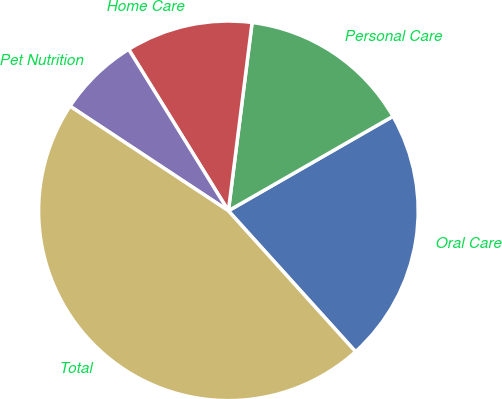Convert chart to OTSL. <chart><loc_0><loc_0><loc_500><loc_500><pie_chart><fcel>Oral Care<fcel>Personal Care<fcel>Home Care<fcel>Pet Nutrition<fcel>Total<nl><fcel>21.61%<fcel>14.71%<fcel>10.8%<fcel>6.9%<fcel>45.98%<nl></chart> 